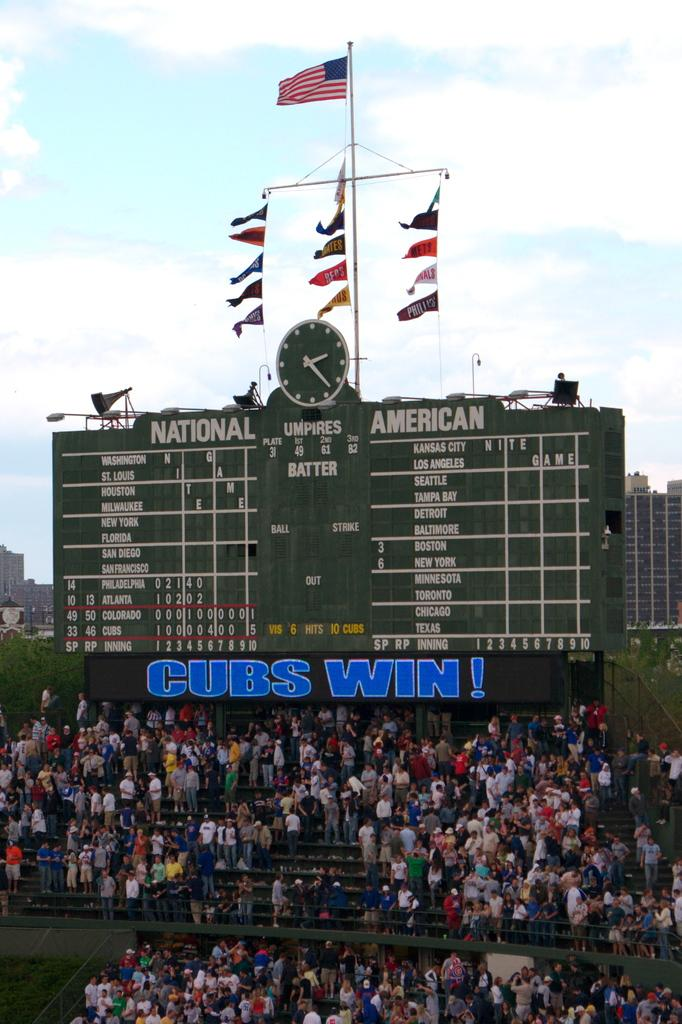<image>
Present a compact description of the photo's key features. A stadium of spectators in the sand with a score board behind them saying Cubs win. 